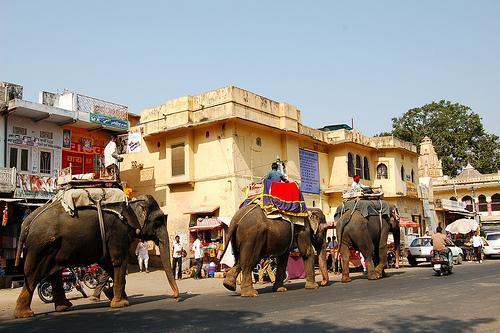How many elephants are shown?
Give a very brief answer. 3. 